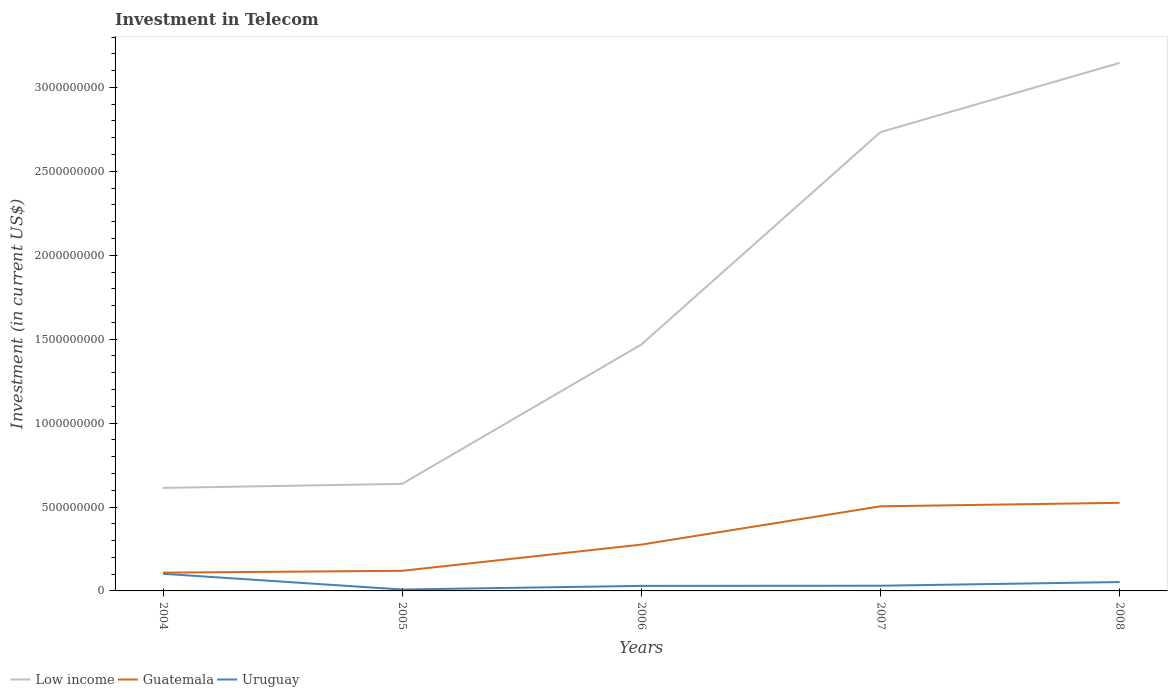How many different coloured lines are there?
Offer a terse response. 3. Is the number of lines equal to the number of legend labels?
Your response must be concise. Yes. Across all years, what is the maximum amount invested in telecom in Low income?
Your answer should be very brief. 6.14e+08. In which year was the amount invested in telecom in Uruguay maximum?
Your response must be concise. 2005. What is the total amount invested in telecom in Low income in the graph?
Your response must be concise. -8.54e+08. What is the difference between the highest and the second highest amount invested in telecom in Low income?
Your answer should be very brief. 2.53e+09. What is the difference between the highest and the lowest amount invested in telecom in Uruguay?
Make the answer very short. 2. What is the difference between two consecutive major ticks on the Y-axis?
Give a very brief answer. 5.00e+08. Does the graph contain grids?
Your response must be concise. No. Where does the legend appear in the graph?
Offer a terse response. Bottom left. How many legend labels are there?
Provide a succinct answer. 3. What is the title of the graph?
Make the answer very short. Investment in Telecom. Does "Israel" appear as one of the legend labels in the graph?
Your response must be concise. No. What is the label or title of the Y-axis?
Offer a terse response. Investment (in current US$). What is the Investment (in current US$) in Low income in 2004?
Make the answer very short. 6.14e+08. What is the Investment (in current US$) in Guatemala in 2004?
Make the answer very short. 1.09e+08. What is the Investment (in current US$) of Uruguay in 2004?
Offer a terse response. 1.02e+08. What is the Investment (in current US$) of Low income in 2005?
Give a very brief answer. 6.38e+08. What is the Investment (in current US$) in Guatemala in 2005?
Your answer should be compact. 1.20e+08. What is the Investment (in current US$) of Uruguay in 2005?
Give a very brief answer. 8.40e+06. What is the Investment (in current US$) in Low income in 2006?
Give a very brief answer. 1.47e+09. What is the Investment (in current US$) of Guatemala in 2006?
Ensure brevity in your answer.  2.76e+08. What is the Investment (in current US$) in Uruguay in 2006?
Provide a short and direct response. 3.00e+07. What is the Investment (in current US$) of Low income in 2007?
Ensure brevity in your answer.  2.73e+09. What is the Investment (in current US$) in Guatemala in 2007?
Provide a succinct answer. 5.04e+08. What is the Investment (in current US$) in Uruguay in 2007?
Provide a succinct answer. 3.09e+07. What is the Investment (in current US$) in Low income in 2008?
Provide a short and direct response. 3.15e+09. What is the Investment (in current US$) of Guatemala in 2008?
Offer a terse response. 5.25e+08. What is the Investment (in current US$) of Uruguay in 2008?
Provide a succinct answer. 5.29e+07. Across all years, what is the maximum Investment (in current US$) in Low income?
Offer a very short reply. 3.15e+09. Across all years, what is the maximum Investment (in current US$) in Guatemala?
Offer a very short reply. 5.25e+08. Across all years, what is the maximum Investment (in current US$) of Uruguay?
Make the answer very short. 1.02e+08. Across all years, what is the minimum Investment (in current US$) of Low income?
Your response must be concise. 6.14e+08. Across all years, what is the minimum Investment (in current US$) of Guatemala?
Your answer should be compact. 1.09e+08. Across all years, what is the minimum Investment (in current US$) in Uruguay?
Make the answer very short. 8.40e+06. What is the total Investment (in current US$) of Low income in the graph?
Your response must be concise. 8.60e+09. What is the total Investment (in current US$) of Guatemala in the graph?
Your response must be concise. 1.53e+09. What is the total Investment (in current US$) of Uruguay in the graph?
Provide a succinct answer. 2.24e+08. What is the difference between the Investment (in current US$) in Low income in 2004 and that in 2005?
Your response must be concise. -2.41e+07. What is the difference between the Investment (in current US$) in Guatemala in 2004 and that in 2005?
Your answer should be very brief. -1.11e+07. What is the difference between the Investment (in current US$) in Uruguay in 2004 and that in 2005?
Your response must be concise. 9.37e+07. What is the difference between the Investment (in current US$) of Low income in 2004 and that in 2006?
Make the answer very short. -8.54e+08. What is the difference between the Investment (in current US$) of Guatemala in 2004 and that in 2006?
Your answer should be very brief. -1.67e+08. What is the difference between the Investment (in current US$) of Uruguay in 2004 and that in 2006?
Offer a very short reply. 7.21e+07. What is the difference between the Investment (in current US$) of Low income in 2004 and that in 2007?
Your answer should be very brief. -2.12e+09. What is the difference between the Investment (in current US$) in Guatemala in 2004 and that in 2007?
Give a very brief answer. -3.95e+08. What is the difference between the Investment (in current US$) in Uruguay in 2004 and that in 2007?
Make the answer very short. 7.12e+07. What is the difference between the Investment (in current US$) of Low income in 2004 and that in 2008?
Provide a succinct answer. -2.53e+09. What is the difference between the Investment (in current US$) in Guatemala in 2004 and that in 2008?
Give a very brief answer. -4.16e+08. What is the difference between the Investment (in current US$) of Uruguay in 2004 and that in 2008?
Offer a very short reply. 4.92e+07. What is the difference between the Investment (in current US$) in Low income in 2005 and that in 2006?
Keep it short and to the point. -8.30e+08. What is the difference between the Investment (in current US$) of Guatemala in 2005 and that in 2006?
Offer a terse response. -1.56e+08. What is the difference between the Investment (in current US$) in Uruguay in 2005 and that in 2006?
Your response must be concise. -2.16e+07. What is the difference between the Investment (in current US$) in Low income in 2005 and that in 2007?
Ensure brevity in your answer.  -2.10e+09. What is the difference between the Investment (in current US$) of Guatemala in 2005 and that in 2007?
Your response must be concise. -3.84e+08. What is the difference between the Investment (in current US$) in Uruguay in 2005 and that in 2007?
Give a very brief answer. -2.25e+07. What is the difference between the Investment (in current US$) in Low income in 2005 and that in 2008?
Keep it short and to the point. -2.51e+09. What is the difference between the Investment (in current US$) of Guatemala in 2005 and that in 2008?
Your response must be concise. -4.05e+08. What is the difference between the Investment (in current US$) in Uruguay in 2005 and that in 2008?
Your answer should be very brief. -4.45e+07. What is the difference between the Investment (in current US$) in Low income in 2006 and that in 2007?
Provide a succinct answer. -1.27e+09. What is the difference between the Investment (in current US$) of Guatemala in 2006 and that in 2007?
Keep it short and to the point. -2.28e+08. What is the difference between the Investment (in current US$) of Uruguay in 2006 and that in 2007?
Provide a short and direct response. -9.00e+05. What is the difference between the Investment (in current US$) of Low income in 2006 and that in 2008?
Provide a succinct answer. -1.68e+09. What is the difference between the Investment (in current US$) in Guatemala in 2006 and that in 2008?
Make the answer very short. -2.49e+08. What is the difference between the Investment (in current US$) in Uruguay in 2006 and that in 2008?
Keep it short and to the point. -2.29e+07. What is the difference between the Investment (in current US$) in Low income in 2007 and that in 2008?
Offer a terse response. -4.12e+08. What is the difference between the Investment (in current US$) in Guatemala in 2007 and that in 2008?
Your answer should be compact. -2.09e+07. What is the difference between the Investment (in current US$) of Uruguay in 2007 and that in 2008?
Your response must be concise. -2.20e+07. What is the difference between the Investment (in current US$) of Low income in 2004 and the Investment (in current US$) of Guatemala in 2005?
Provide a succinct answer. 4.94e+08. What is the difference between the Investment (in current US$) of Low income in 2004 and the Investment (in current US$) of Uruguay in 2005?
Your answer should be compact. 6.05e+08. What is the difference between the Investment (in current US$) in Guatemala in 2004 and the Investment (in current US$) in Uruguay in 2005?
Ensure brevity in your answer.  1.00e+08. What is the difference between the Investment (in current US$) in Low income in 2004 and the Investment (in current US$) in Guatemala in 2006?
Your response must be concise. 3.38e+08. What is the difference between the Investment (in current US$) of Low income in 2004 and the Investment (in current US$) of Uruguay in 2006?
Provide a succinct answer. 5.84e+08. What is the difference between the Investment (in current US$) in Guatemala in 2004 and the Investment (in current US$) in Uruguay in 2006?
Your response must be concise. 7.88e+07. What is the difference between the Investment (in current US$) in Low income in 2004 and the Investment (in current US$) in Guatemala in 2007?
Provide a short and direct response. 1.10e+08. What is the difference between the Investment (in current US$) of Low income in 2004 and the Investment (in current US$) of Uruguay in 2007?
Your answer should be very brief. 5.83e+08. What is the difference between the Investment (in current US$) in Guatemala in 2004 and the Investment (in current US$) in Uruguay in 2007?
Offer a very short reply. 7.79e+07. What is the difference between the Investment (in current US$) of Low income in 2004 and the Investment (in current US$) of Guatemala in 2008?
Your answer should be compact. 8.88e+07. What is the difference between the Investment (in current US$) of Low income in 2004 and the Investment (in current US$) of Uruguay in 2008?
Your response must be concise. 5.61e+08. What is the difference between the Investment (in current US$) of Guatemala in 2004 and the Investment (in current US$) of Uruguay in 2008?
Give a very brief answer. 5.59e+07. What is the difference between the Investment (in current US$) in Low income in 2005 and the Investment (in current US$) in Guatemala in 2006?
Ensure brevity in your answer.  3.62e+08. What is the difference between the Investment (in current US$) of Low income in 2005 and the Investment (in current US$) of Uruguay in 2006?
Provide a short and direct response. 6.08e+08. What is the difference between the Investment (in current US$) of Guatemala in 2005 and the Investment (in current US$) of Uruguay in 2006?
Ensure brevity in your answer.  8.99e+07. What is the difference between the Investment (in current US$) in Low income in 2005 and the Investment (in current US$) in Guatemala in 2007?
Your answer should be very brief. 1.34e+08. What is the difference between the Investment (in current US$) in Low income in 2005 and the Investment (in current US$) in Uruguay in 2007?
Make the answer very short. 6.07e+08. What is the difference between the Investment (in current US$) of Guatemala in 2005 and the Investment (in current US$) of Uruguay in 2007?
Give a very brief answer. 8.90e+07. What is the difference between the Investment (in current US$) in Low income in 2005 and the Investment (in current US$) in Guatemala in 2008?
Provide a short and direct response. 1.13e+08. What is the difference between the Investment (in current US$) of Low income in 2005 and the Investment (in current US$) of Uruguay in 2008?
Your answer should be compact. 5.85e+08. What is the difference between the Investment (in current US$) of Guatemala in 2005 and the Investment (in current US$) of Uruguay in 2008?
Ensure brevity in your answer.  6.70e+07. What is the difference between the Investment (in current US$) of Low income in 2006 and the Investment (in current US$) of Guatemala in 2007?
Ensure brevity in your answer.  9.64e+08. What is the difference between the Investment (in current US$) in Low income in 2006 and the Investment (in current US$) in Uruguay in 2007?
Give a very brief answer. 1.44e+09. What is the difference between the Investment (in current US$) of Guatemala in 2006 and the Investment (in current US$) of Uruguay in 2007?
Provide a succinct answer. 2.45e+08. What is the difference between the Investment (in current US$) of Low income in 2006 and the Investment (in current US$) of Guatemala in 2008?
Give a very brief answer. 9.43e+08. What is the difference between the Investment (in current US$) in Low income in 2006 and the Investment (in current US$) in Uruguay in 2008?
Keep it short and to the point. 1.42e+09. What is the difference between the Investment (in current US$) of Guatemala in 2006 and the Investment (in current US$) of Uruguay in 2008?
Provide a succinct answer. 2.23e+08. What is the difference between the Investment (in current US$) in Low income in 2007 and the Investment (in current US$) in Guatemala in 2008?
Give a very brief answer. 2.21e+09. What is the difference between the Investment (in current US$) of Low income in 2007 and the Investment (in current US$) of Uruguay in 2008?
Provide a short and direct response. 2.68e+09. What is the difference between the Investment (in current US$) in Guatemala in 2007 and the Investment (in current US$) in Uruguay in 2008?
Ensure brevity in your answer.  4.51e+08. What is the average Investment (in current US$) in Low income per year?
Offer a terse response. 1.72e+09. What is the average Investment (in current US$) of Guatemala per year?
Give a very brief answer. 3.07e+08. What is the average Investment (in current US$) in Uruguay per year?
Provide a succinct answer. 4.49e+07. In the year 2004, what is the difference between the Investment (in current US$) of Low income and Investment (in current US$) of Guatemala?
Provide a short and direct response. 5.05e+08. In the year 2004, what is the difference between the Investment (in current US$) in Low income and Investment (in current US$) in Uruguay?
Your answer should be very brief. 5.12e+08. In the year 2004, what is the difference between the Investment (in current US$) of Guatemala and Investment (in current US$) of Uruguay?
Offer a very short reply. 6.70e+06. In the year 2005, what is the difference between the Investment (in current US$) of Low income and Investment (in current US$) of Guatemala?
Your answer should be compact. 5.18e+08. In the year 2005, what is the difference between the Investment (in current US$) in Low income and Investment (in current US$) in Uruguay?
Provide a succinct answer. 6.29e+08. In the year 2005, what is the difference between the Investment (in current US$) of Guatemala and Investment (in current US$) of Uruguay?
Offer a terse response. 1.12e+08. In the year 2006, what is the difference between the Investment (in current US$) in Low income and Investment (in current US$) in Guatemala?
Provide a succinct answer. 1.19e+09. In the year 2006, what is the difference between the Investment (in current US$) in Low income and Investment (in current US$) in Uruguay?
Give a very brief answer. 1.44e+09. In the year 2006, what is the difference between the Investment (in current US$) in Guatemala and Investment (in current US$) in Uruguay?
Keep it short and to the point. 2.46e+08. In the year 2007, what is the difference between the Investment (in current US$) of Low income and Investment (in current US$) of Guatemala?
Your response must be concise. 2.23e+09. In the year 2007, what is the difference between the Investment (in current US$) in Low income and Investment (in current US$) in Uruguay?
Provide a succinct answer. 2.70e+09. In the year 2007, what is the difference between the Investment (in current US$) in Guatemala and Investment (in current US$) in Uruguay?
Keep it short and to the point. 4.73e+08. In the year 2008, what is the difference between the Investment (in current US$) in Low income and Investment (in current US$) in Guatemala?
Your answer should be very brief. 2.62e+09. In the year 2008, what is the difference between the Investment (in current US$) in Low income and Investment (in current US$) in Uruguay?
Ensure brevity in your answer.  3.09e+09. In the year 2008, what is the difference between the Investment (in current US$) in Guatemala and Investment (in current US$) in Uruguay?
Ensure brevity in your answer.  4.72e+08. What is the ratio of the Investment (in current US$) in Low income in 2004 to that in 2005?
Offer a terse response. 0.96. What is the ratio of the Investment (in current US$) in Guatemala in 2004 to that in 2005?
Keep it short and to the point. 0.91. What is the ratio of the Investment (in current US$) of Uruguay in 2004 to that in 2005?
Make the answer very short. 12.15. What is the ratio of the Investment (in current US$) of Low income in 2004 to that in 2006?
Provide a succinct answer. 0.42. What is the ratio of the Investment (in current US$) in Guatemala in 2004 to that in 2006?
Ensure brevity in your answer.  0.39. What is the ratio of the Investment (in current US$) of Uruguay in 2004 to that in 2006?
Your response must be concise. 3.4. What is the ratio of the Investment (in current US$) of Low income in 2004 to that in 2007?
Give a very brief answer. 0.22. What is the ratio of the Investment (in current US$) of Guatemala in 2004 to that in 2007?
Provide a short and direct response. 0.22. What is the ratio of the Investment (in current US$) of Uruguay in 2004 to that in 2007?
Your response must be concise. 3.3. What is the ratio of the Investment (in current US$) in Low income in 2004 to that in 2008?
Keep it short and to the point. 0.2. What is the ratio of the Investment (in current US$) of Guatemala in 2004 to that in 2008?
Keep it short and to the point. 0.21. What is the ratio of the Investment (in current US$) in Uruguay in 2004 to that in 2008?
Your response must be concise. 1.93. What is the ratio of the Investment (in current US$) in Low income in 2005 to that in 2006?
Make the answer very short. 0.43. What is the ratio of the Investment (in current US$) of Guatemala in 2005 to that in 2006?
Your answer should be compact. 0.43. What is the ratio of the Investment (in current US$) of Uruguay in 2005 to that in 2006?
Give a very brief answer. 0.28. What is the ratio of the Investment (in current US$) of Low income in 2005 to that in 2007?
Give a very brief answer. 0.23. What is the ratio of the Investment (in current US$) of Guatemala in 2005 to that in 2007?
Provide a succinct answer. 0.24. What is the ratio of the Investment (in current US$) of Uruguay in 2005 to that in 2007?
Offer a terse response. 0.27. What is the ratio of the Investment (in current US$) of Low income in 2005 to that in 2008?
Make the answer very short. 0.2. What is the ratio of the Investment (in current US$) in Guatemala in 2005 to that in 2008?
Give a very brief answer. 0.23. What is the ratio of the Investment (in current US$) in Uruguay in 2005 to that in 2008?
Your answer should be compact. 0.16. What is the ratio of the Investment (in current US$) of Low income in 2006 to that in 2007?
Provide a succinct answer. 0.54. What is the ratio of the Investment (in current US$) of Guatemala in 2006 to that in 2007?
Your answer should be very brief. 0.55. What is the ratio of the Investment (in current US$) of Uruguay in 2006 to that in 2007?
Make the answer very short. 0.97. What is the ratio of the Investment (in current US$) in Low income in 2006 to that in 2008?
Make the answer very short. 0.47. What is the ratio of the Investment (in current US$) in Guatemala in 2006 to that in 2008?
Give a very brief answer. 0.53. What is the ratio of the Investment (in current US$) of Uruguay in 2006 to that in 2008?
Keep it short and to the point. 0.57. What is the ratio of the Investment (in current US$) of Low income in 2007 to that in 2008?
Make the answer very short. 0.87. What is the ratio of the Investment (in current US$) in Guatemala in 2007 to that in 2008?
Your answer should be compact. 0.96. What is the ratio of the Investment (in current US$) in Uruguay in 2007 to that in 2008?
Your answer should be very brief. 0.58. What is the difference between the highest and the second highest Investment (in current US$) of Low income?
Provide a short and direct response. 4.12e+08. What is the difference between the highest and the second highest Investment (in current US$) of Guatemala?
Make the answer very short. 2.09e+07. What is the difference between the highest and the second highest Investment (in current US$) in Uruguay?
Your answer should be very brief. 4.92e+07. What is the difference between the highest and the lowest Investment (in current US$) of Low income?
Give a very brief answer. 2.53e+09. What is the difference between the highest and the lowest Investment (in current US$) in Guatemala?
Offer a terse response. 4.16e+08. What is the difference between the highest and the lowest Investment (in current US$) in Uruguay?
Give a very brief answer. 9.37e+07. 